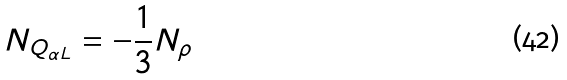<formula> <loc_0><loc_0><loc_500><loc_500>N _ { Q _ { \alpha L } } = - \frac { 1 } { 3 } N _ { \rho }</formula> 